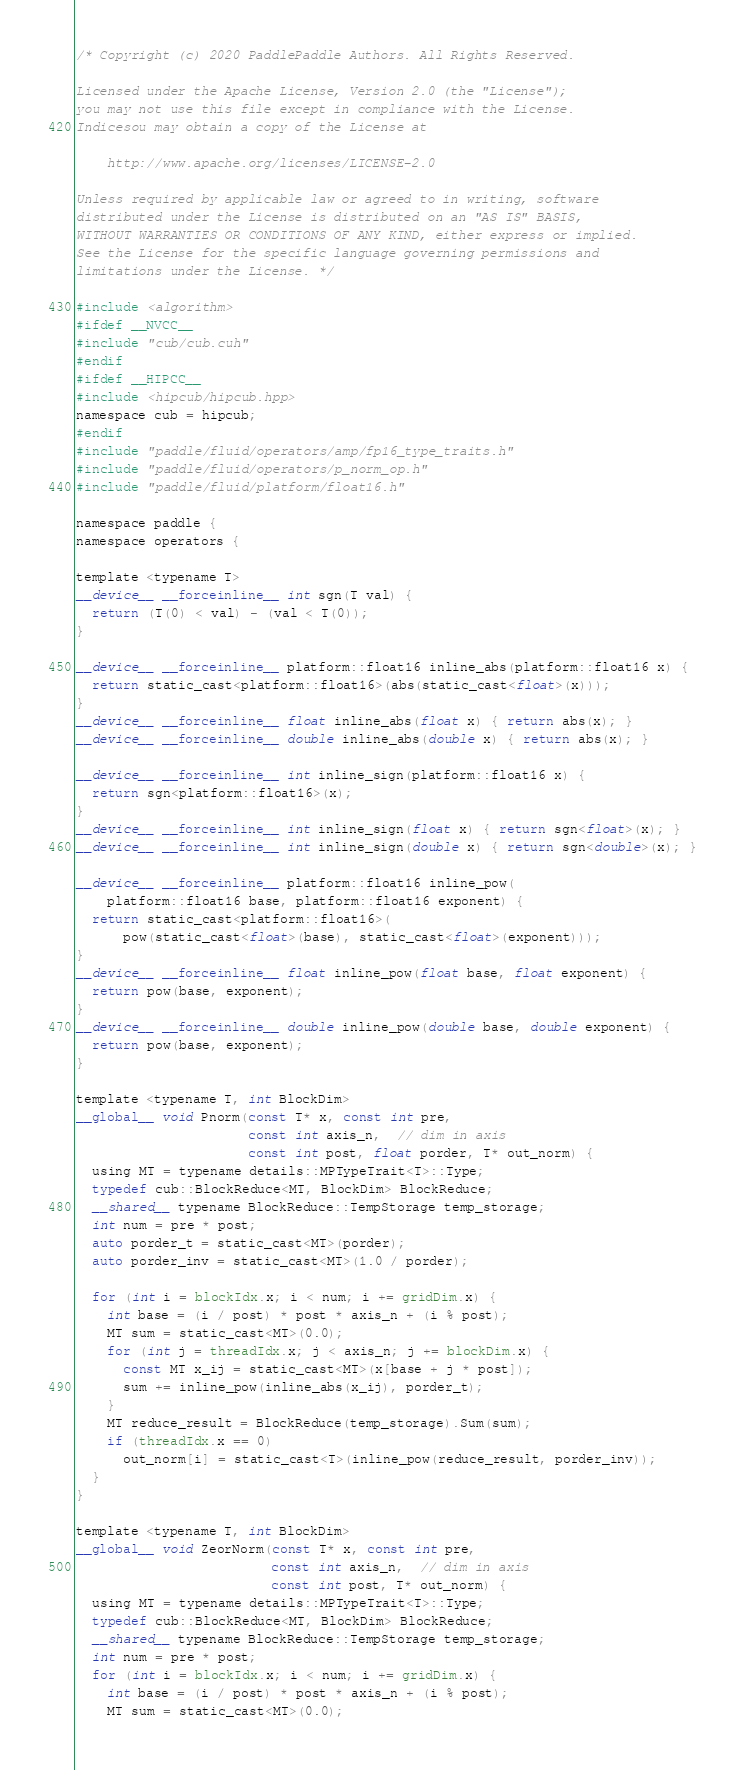<code> <loc_0><loc_0><loc_500><loc_500><_Cuda_>/* Copyright (c) 2020 PaddlePaddle Authors. All Rights Reserved.

Licensed under the Apache License, Version 2.0 (the "License");
you may not use this file except in compliance with the License.
Indicesou may obtain a copy of the License at

    http://www.apache.org/licenses/LICENSE-2.0

Unless required by applicable law or agreed to in writing, software
distributed under the License is distributed on an "AS IS" BASIS,
WITHOUT WARRANTIES OR CONDITIONS OF ANY KIND, either express or implied.
See the License for the specific language governing permissions and
limitations under the License. */

#include <algorithm>
#ifdef __NVCC__
#include "cub/cub.cuh"
#endif
#ifdef __HIPCC__
#include <hipcub/hipcub.hpp>
namespace cub = hipcub;
#endif
#include "paddle/fluid/operators/amp/fp16_type_traits.h"
#include "paddle/fluid/operators/p_norm_op.h"
#include "paddle/fluid/platform/float16.h"

namespace paddle {
namespace operators {

template <typename T>
__device__ __forceinline__ int sgn(T val) {
  return (T(0) < val) - (val < T(0));
}

__device__ __forceinline__ platform::float16 inline_abs(platform::float16 x) {
  return static_cast<platform::float16>(abs(static_cast<float>(x)));
}
__device__ __forceinline__ float inline_abs(float x) { return abs(x); }
__device__ __forceinline__ double inline_abs(double x) { return abs(x); }

__device__ __forceinline__ int inline_sign(platform::float16 x) {
  return sgn<platform::float16>(x);
}
__device__ __forceinline__ int inline_sign(float x) { return sgn<float>(x); }
__device__ __forceinline__ int inline_sign(double x) { return sgn<double>(x); }

__device__ __forceinline__ platform::float16 inline_pow(
    platform::float16 base, platform::float16 exponent) {
  return static_cast<platform::float16>(
      pow(static_cast<float>(base), static_cast<float>(exponent)));
}
__device__ __forceinline__ float inline_pow(float base, float exponent) {
  return pow(base, exponent);
}
__device__ __forceinline__ double inline_pow(double base, double exponent) {
  return pow(base, exponent);
}

template <typename T, int BlockDim>
__global__ void Pnorm(const T* x, const int pre,
                      const int axis_n,  // dim in axis
                      const int post, float porder, T* out_norm) {
  using MT = typename details::MPTypeTrait<T>::Type;
  typedef cub::BlockReduce<MT, BlockDim> BlockReduce;
  __shared__ typename BlockReduce::TempStorage temp_storage;
  int num = pre * post;
  auto porder_t = static_cast<MT>(porder);
  auto porder_inv = static_cast<MT>(1.0 / porder);

  for (int i = blockIdx.x; i < num; i += gridDim.x) {
    int base = (i / post) * post * axis_n + (i % post);
    MT sum = static_cast<MT>(0.0);
    for (int j = threadIdx.x; j < axis_n; j += blockDim.x) {
      const MT x_ij = static_cast<MT>(x[base + j * post]);
      sum += inline_pow(inline_abs(x_ij), porder_t);
    }
    MT reduce_result = BlockReduce(temp_storage).Sum(sum);
    if (threadIdx.x == 0)
      out_norm[i] = static_cast<T>(inline_pow(reduce_result, porder_inv));
  }
}

template <typename T, int BlockDim>
__global__ void ZeorNorm(const T* x, const int pre,
                         const int axis_n,  // dim in axis
                         const int post, T* out_norm) {
  using MT = typename details::MPTypeTrait<T>::Type;
  typedef cub::BlockReduce<MT, BlockDim> BlockReduce;
  __shared__ typename BlockReduce::TempStorage temp_storage;
  int num = pre * post;
  for (int i = blockIdx.x; i < num; i += gridDim.x) {
    int base = (i / post) * post * axis_n + (i % post);
    MT sum = static_cast<MT>(0.0);</code> 